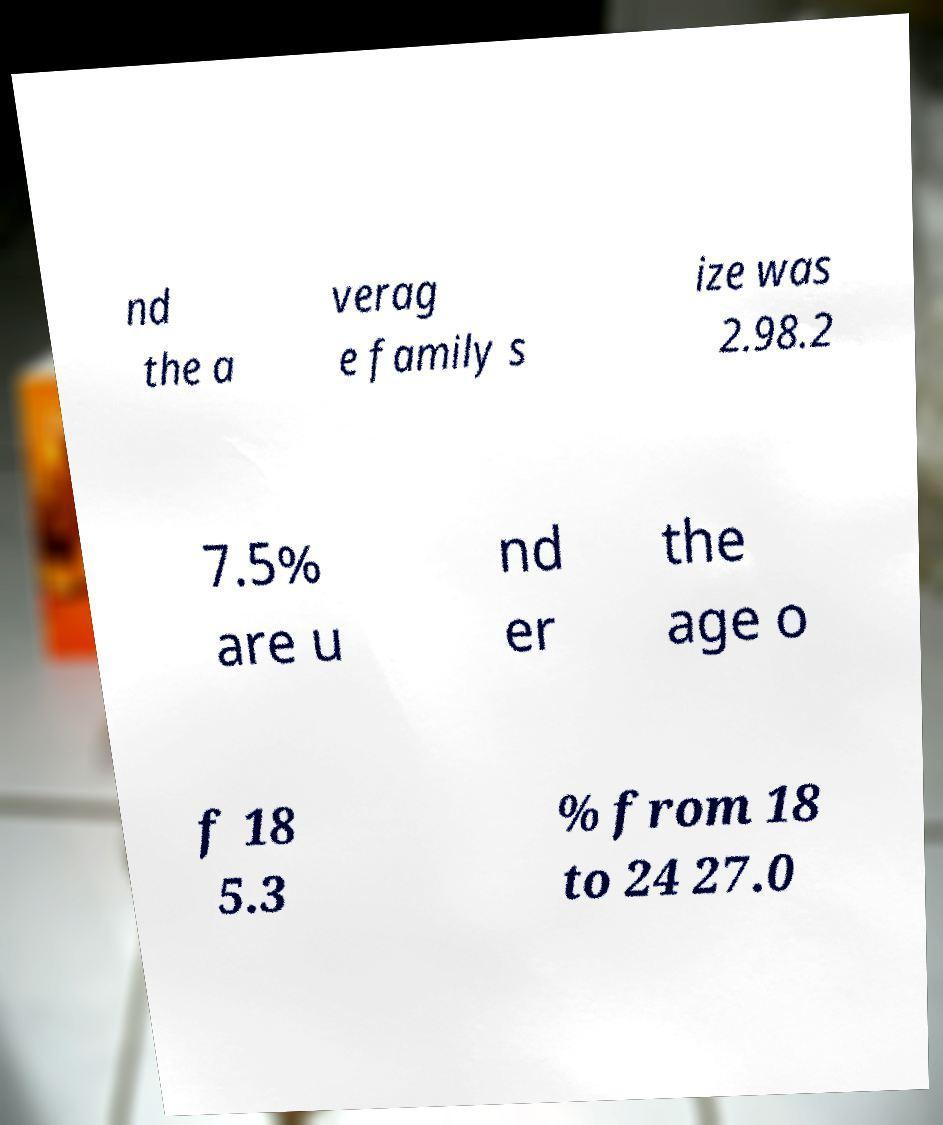I need the written content from this picture converted into text. Can you do that? nd the a verag e family s ize was 2.98.2 7.5% are u nd er the age o f 18 5.3 % from 18 to 24 27.0 